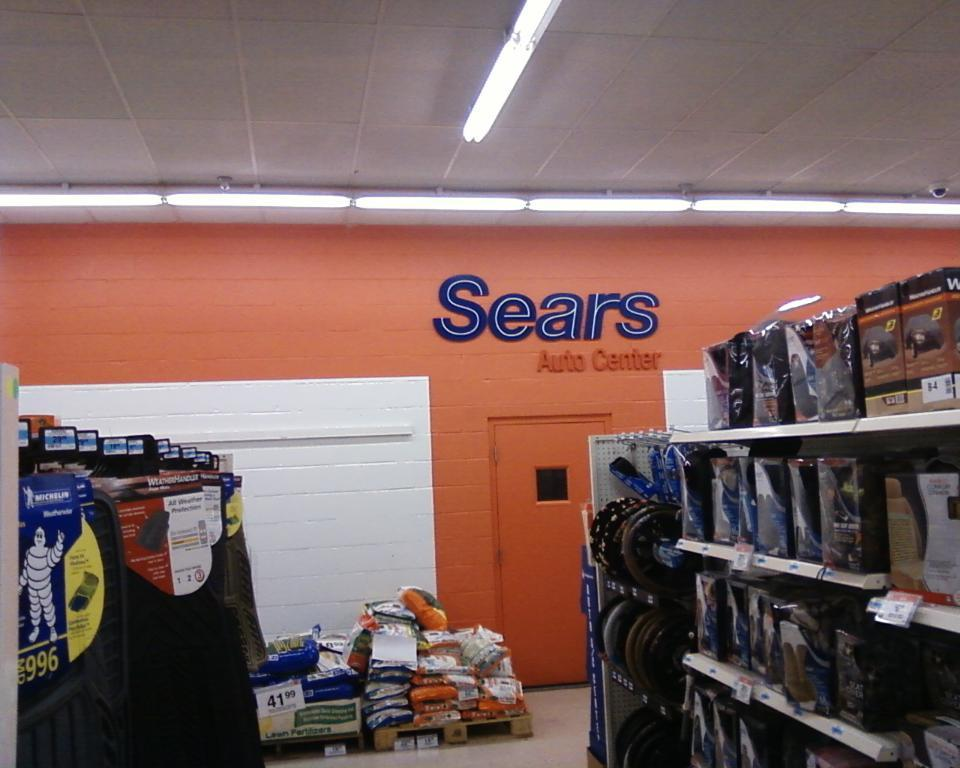<image>
Provide a brief description of the given image. An orange wall with a blue Sears sign on it. 